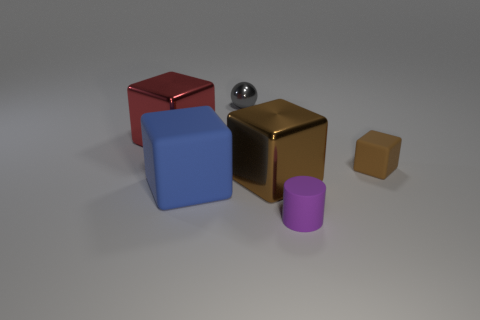Subtract all cyan cubes. Subtract all green spheres. How many cubes are left? 4 Add 3 large blue matte objects. How many objects exist? 9 Subtract all cylinders. How many objects are left? 5 Add 2 gray metallic balls. How many gray metallic balls are left? 3 Add 6 small blue blocks. How many small blue blocks exist? 6 Subtract 0 yellow blocks. How many objects are left? 6 Subtract all tiny shiny objects. Subtract all big blue matte things. How many objects are left? 4 